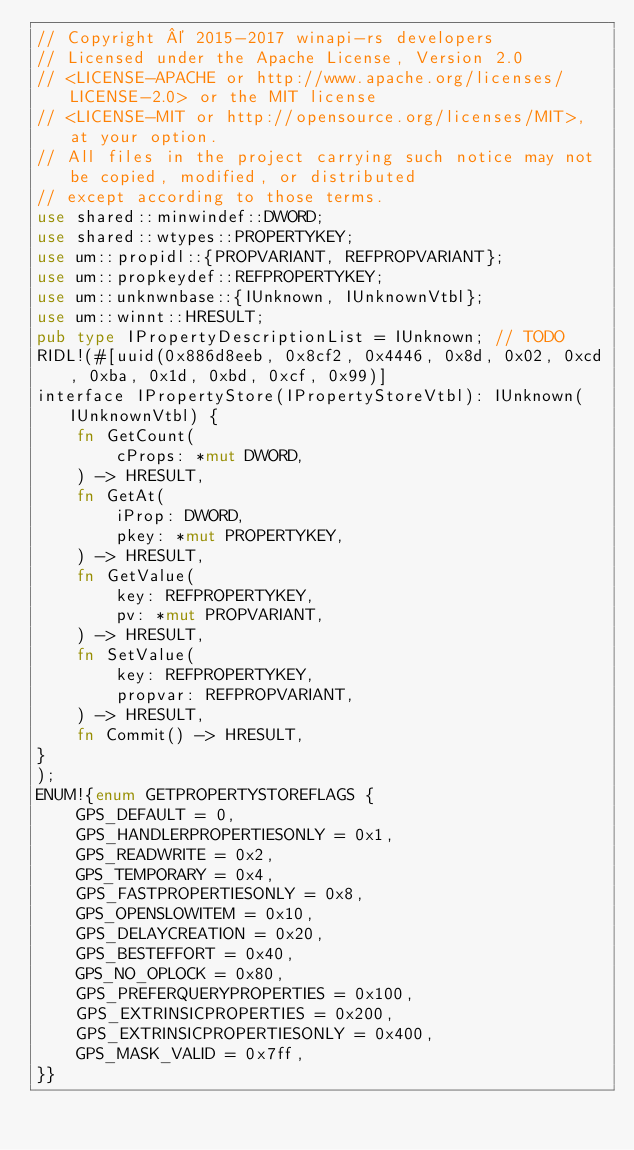<code> <loc_0><loc_0><loc_500><loc_500><_Rust_>// Copyright © 2015-2017 winapi-rs developers
// Licensed under the Apache License, Version 2.0
// <LICENSE-APACHE or http://www.apache.org/licenses/LICENSE-2.0> or the MIT license
// <LICENSE-MIT or http://opensource.org/licenses/MIT>, at your option.
// All files in the project carrying such notice may not be copied, modified, or distributed
// except according to those terms.
use shared::minwindef::DWORD;
use shared::wtypes::PROPERTYKEY;
use um::propidl::{PROPVARIANT, REFPROPVARIANT};
use um::propkeydef::REFPROPERTYKEY;
use um::unknwnbase::{IUnknown, IUnknownVtbl};
use um::winnt::HRESULT;
pub type IPropertyDescriptionList = IUnknown; // TODO
RIDL!(#[uuid(0x886d8eeb, 0x8cf2, 0x4446, 0x8d, 0x02, 0xcd, 0xba, 0x1d, 0xbd, 0xcf, 0x99)]
interface IPropertyStore(IPropertyStoreVtbl): IUnknown(IUnknownVtbl) {
    fn GetCount( 
        cProps: *mut DWORD,
    ) -> HRESULT,
    fn GetAt( 
        iProp: DWORD,
        pkey: *mut PROPERTYKEY,
    ) -> HRESULT,
    fn GetValue( 
        key: REFPROPERTYKEY,
        pv: *mut PROPVARIANT,
    ) -> HRESULT,
    fn SetValue( 
        key: REFPROPERTYKEY,
        propvar: REFPROPVARIANT,
    ) -> HRESULT,
    fn Commit() -> HRESULT,
}
);
ENUM!{enum GETPROPERTYSTOREFLAGS {
    GPS_DEFAULT = 0,
    GPS_HANDLERPROPERTIESONLY = 0x1,
    GPS_READWRITE = 0x2,
    GPS_TEMPORARY = 0x4,
    GPS_FASTPROPERTIESONLY = 0x8,
    GPS_OPENSLOWITEM = 0x10,
    GPS_DELAYCREATION = 0x20,
    GPS_BESTEFFORT = 0x40,
    GPS_NO_OPLOCK = 0x80,
    GPS_PREFERQUERYPROPERTIES = 0x100,
    GPS_EXTRINSICPROPERTIES = 0x200,
    GPS_EXTRINSICPROPERTIESONLY = 0x400,
    GPS_MASK_VALID = 0x7ff,
}}
</code> 